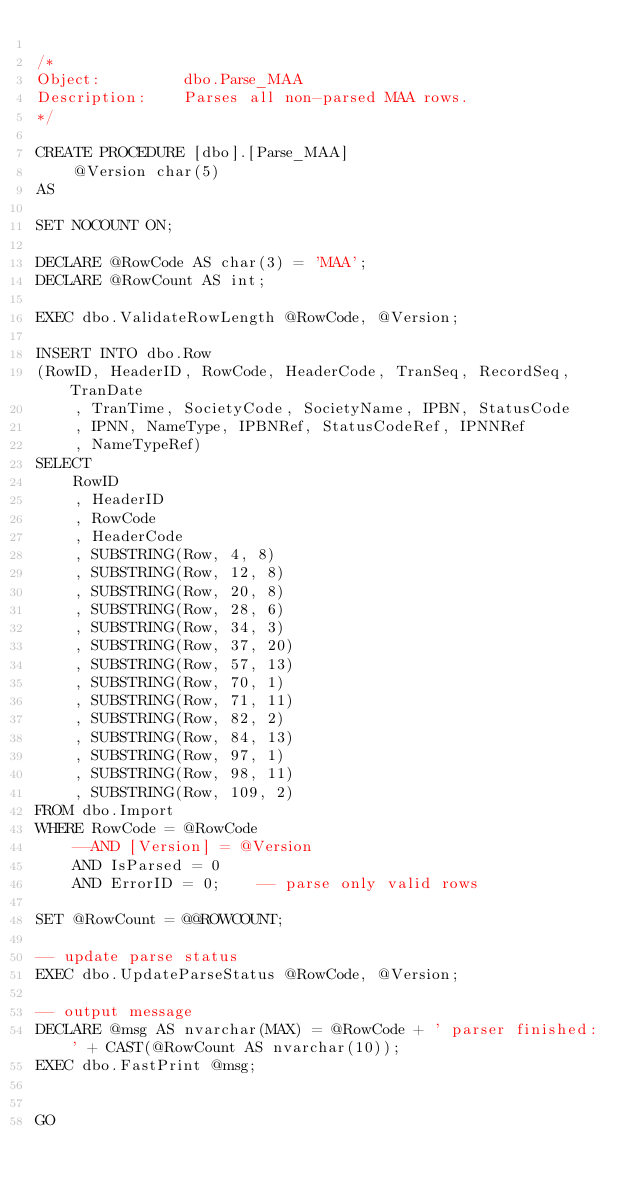Convert code to text. <code><loc_0><loc_0><loc_500><loc_500><_SQL_>
/*
Object:			dbo.Parse_MAA
Description:	Parses all non-parsed MAA rows.
*/

CREATE PROCEDURE [dbo].[Parse_MAA]
	@Version char(5)
AS

SET NOCOUNT ON;

DECLARE @RowCode AS char(3) = 'MAA';
DECLARE @RowCount AS int;

EXEC dbo.ValidateRowLength @RowCode, @Version;

INSERT INTO dbo.Row
(RowID, HeaderID, RowCode, HeaderCode, TranSeq, RecordSeq, TranDate
	, TranTime, SocietyCode, SocietyName, IPBN, StatusCode
	, IPNN, NameType, IPBNRef, StatusCodeRef, IPNNRef
	, NameTypeRef)
SELECT 
	RowID
	, HeaderID
	, RowCode
	, HeaderCode
	, SUBSTRING(Row, 4, 8)
	, SUBSTRING(Row, 12, 8)
	, SUBSTRING(Row, 20, 8)
	, SUBSTRING(Row, 28, 6)
	, SUBSTRING(Row, 34, 3)
	, SUBSTRING(Row, 37, 20)
	, SUBSTRING(Row, 57, 13)
	, SUBSTRING(Row, 70, 1)
	, SUBSTRING(Row, 71, 11)
	, SUBSTRING(Row, 82, 2)
	, SUBSTRING(Row, 84, 13)
	, SUBSTRING(Row, 97, 1)
	, SUBSTRING(Row, 98, 11)
	, SUBSTRING(Row, 109, 2)
FROM dbo.Import
WHERE RowCode = @RowCode
	--AND [Version] = @Version
	AND IsParsed = 0
	AND ErrorID = 0;	-- parse only valid rows

SET @RowCount = @@ROWCOUNT;

-- update parse status
EXEC dbo.UpdateParseStatus @RowCode, @Version;

-- output message
DECLARE @msg AS nvarchar(MAX) = @RowCode + ' parser finished: ' + CAST(@RowCount AS nvarchar(10));
EXEC dbo.FastPrint @msg;


GO


</code> 